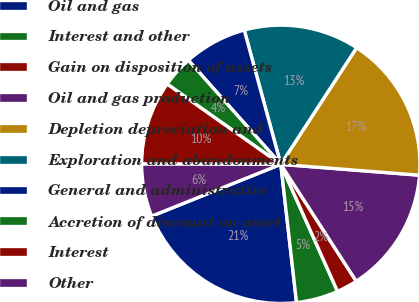Convert chart. <chart><loc_0><loc_0><loc_500><loc_500><pie_chart><fcel>Oil and gas<fcel>Interest and other<fcel>Gain on disposition of assets<fcel>Oil and gas production<fcel>Depletion depreciation and<fcel>Exploration and abandonments<fcel>General and administrative<fcel>Accretion of discount on asset<fcel>Interest<fcel>Other<nl><fcel>20.73%<fcel>4.88%<fcel>2.44%<fcel>14.63%<fcel>17.07%<fcel>13.41%<fcel>7.32%<fcel>3.66%<fcel>9.76%<fcel>6.1%<nl></chart> 